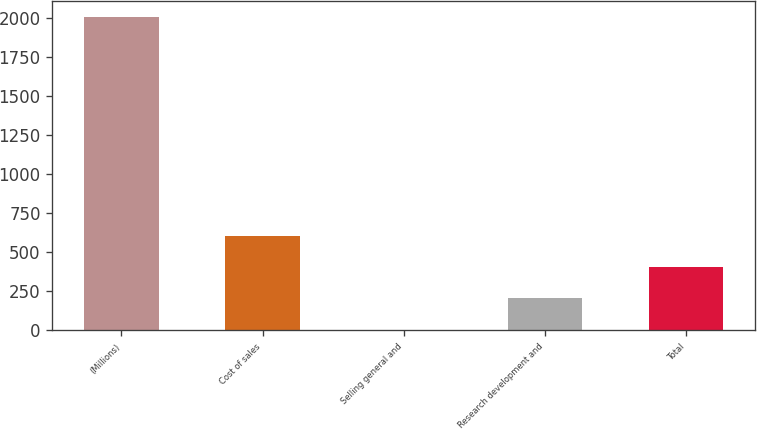Convert chart. <chart><loc_0><loc_0><loc_500><loc_500><bar_chart><fcel>(Millions)<fcel>Cost of sales<fcel>Selling general and<fcel>Research development and<fcel>Total<nl><fcel>2007<fcel>605.6<fcel>5<fcel>205.2<fcel>405.4<nl></chart> 